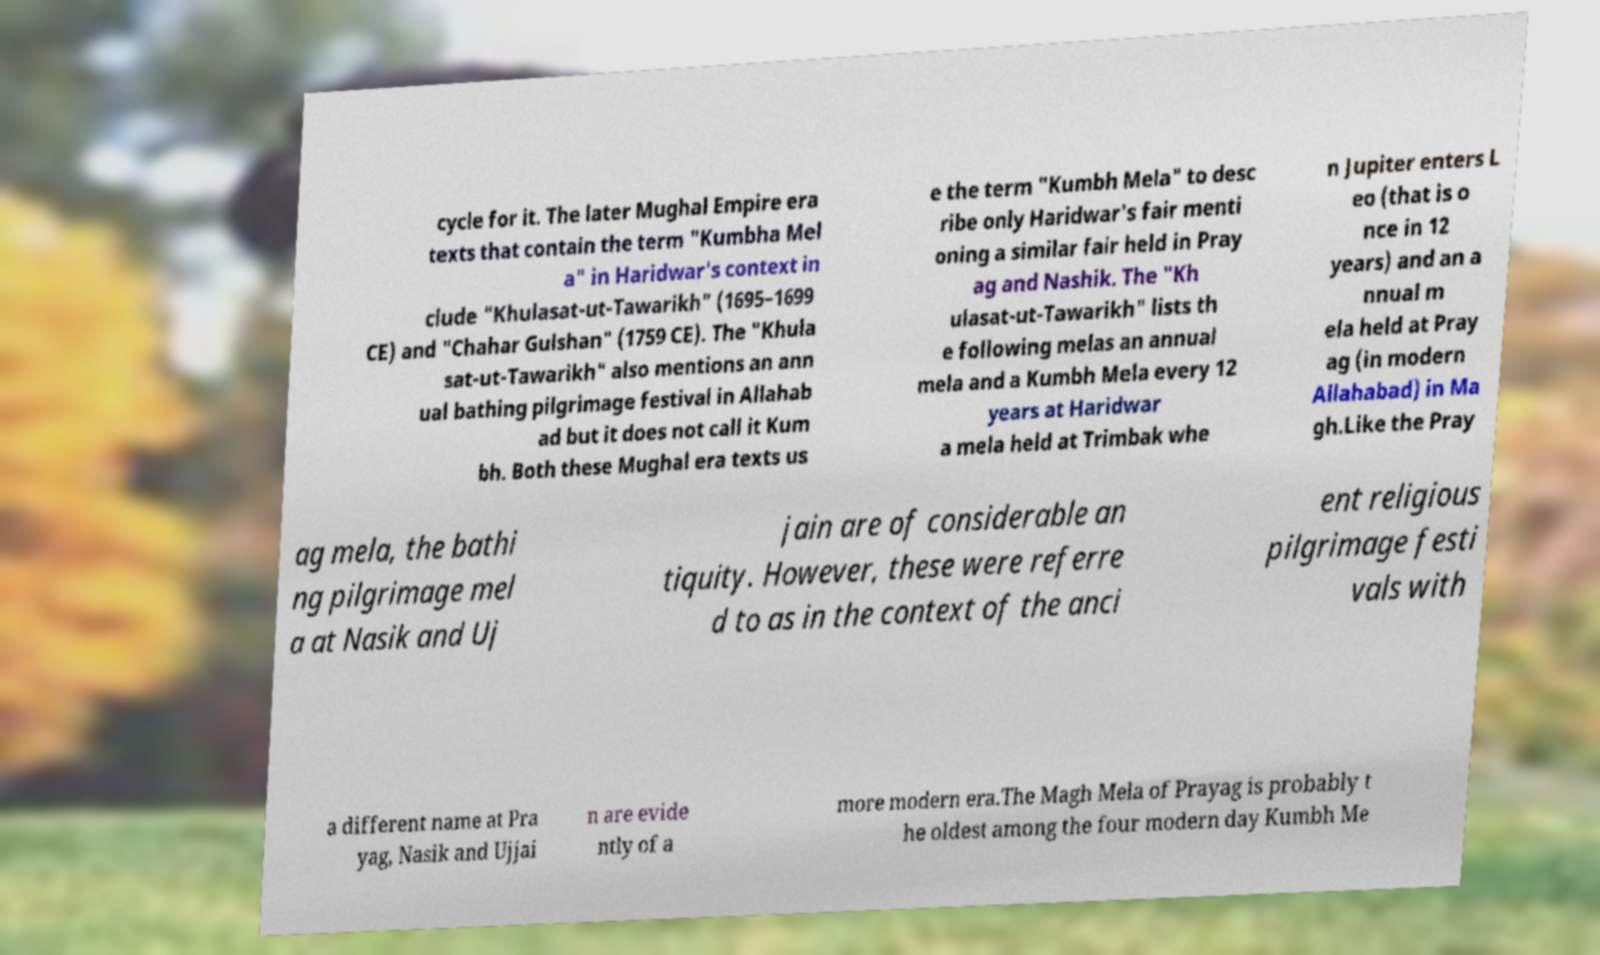What messages or text are displayed in this image? I need them in a readable, typed format. cycle for it. The later Mughal Empire era texts that contain the term "Kumbha Mel a" in Haridwar's context in clude "Khulasat-ut-Tawarikh" (1695–1699 CE) and "Chahar Gulshan" (1759 CE). The "Khula sat-ut-Tawarikh" also mentions an ann ual bathing pilgrimage festival in Allahab ad but it does not call it Kum bh. Both these Mughal era texts us e the term "Kumbh Mela" to desc ribe only Haridwar's fair menti oning a similar fair held in Pray ag and Nashik. The "Kh ulasat-ut-Tawarikh" lists th e following melas an annual mela and a Kumbh Mela every 12 years at Haridwar a mela held at Trimbak whe n Jupiter enters L eo (that is o nce in 12 years) and an a nnual m ela held at Pray ag (in modern Allahabad) in Ma gh.Like the Pray ag mela, the bathi ng pilgrimage mel a at Nasik and Uj jain are of considerable an tiquity. However, these were referre d to as in the context of the anci ent religious pilgrimage festi vals with a different name at Pra yag, Nasik and Ujjai n are evide ntly of a more modern era.The Magh Mela of Prayag is probably t he oldest among the four modern day Kumbh Me 